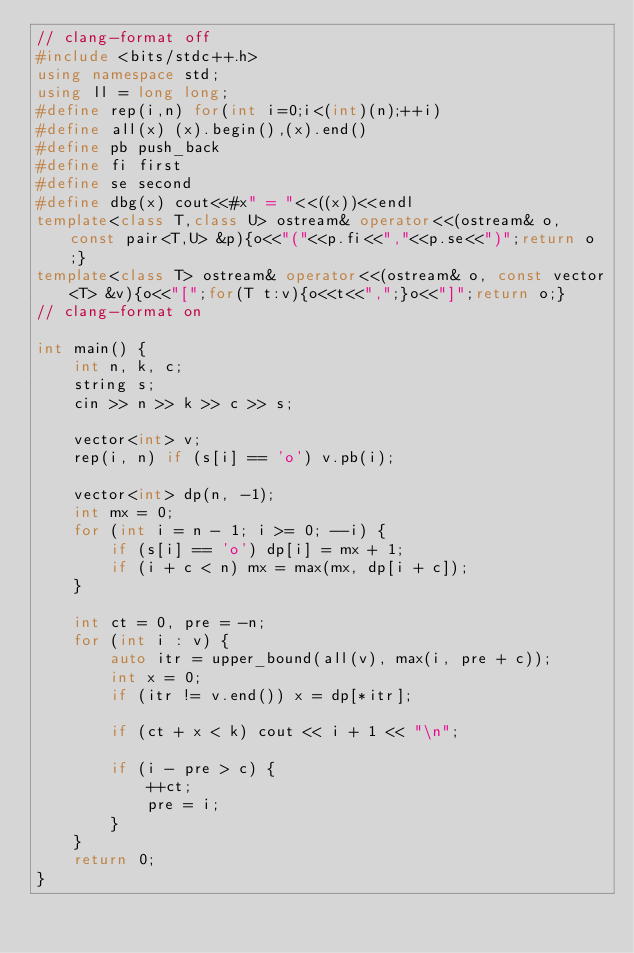<code> <loc_0><loc_0><loc_500><loc_500><_C++_>// clang-format off
#include <bits/stdc++.h>
using namespace std;
using ll = long long;
#define rep(i,n) for(int i=0;i<(int)(n);++i)
#define all(x) (x).begin(),(x).end()
#define pb push_back
#define fi first
#define se second
#define dbg(x) cout<<#x" = "<<((x))<<endl
template<class T,class U> ostream& operator<<(ostream& o, const pair<T,U> &p){o<<"("<<p.fi<<","<<p.se<<")";return o;}
template<class T> ostream& operator<<(ostream& o, const vector<T> &v){o<<"[";for(T t:v){o<<t<<",";}o<<"]";return o;}
// clang-format on

int main() {
    int n, k, c;
    string s;
    cin >> n >> k >> c >> s;

    vector<int> v;
    rep(i, n) if (s[i] == 'o') v.pb(i);

    vector<int> dp(n, -1);
    int mx = 0;
    for (int i = n - 1; i >= 0; --i) {
        if (s[i] == 'o') dp[i] = mx + 1;
        if (i + c < n) mx = max(mx, dp[i + c]);
    }

    int ct = 0, pre = -n;
    for (int i : v) {
        auto itr = upper_bound(all(v), max(i, pre + c));
        int x = 0;
        if (itr != v.end()) x = dp[*itr];

        if (ct + x < k) cout << i + 1 << "\n";

        if (i - pre > c) {
            ++ct;
            pre = i;
        }
    }
    return 0;
}
</code> 